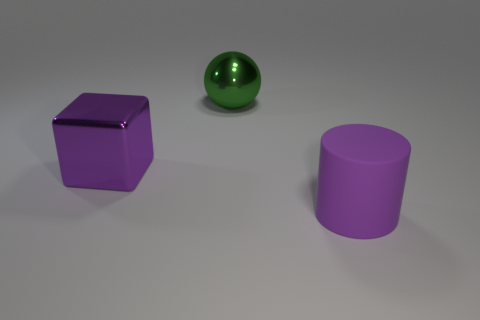There is a big object that is the same color as the big metallic cube; what is it made of?
Give a very brief answer. Rubber. Is there any other thing that is made of the same material as the large cylinder?
Your answer should be compact. No. Is the rubber cylinder the same color as the shiny cube?
Your answer should be very brief. Yes. Is there a metallic thing of the same color as the cylinder?
Keep it short and to the point. Yes. There is a metallic block that is the same color as the large cylinder; what is its size?
Provide a short and direct response. Large. There is a thing that is to the left of the large green metal sphere; is its color the same as the big object on the right side of the large green thing?
Ensure brevity in your answer.  Yes. What size is the purple rubber thing?
Your answer should be compact. Large. What number of small objects are green metallic balls or purple cylinders?
Make the answer very short. 0. What is the color of the matte cylinder that is the same size as the metal sphere?
Your answer should be very brief. Purple. What number of other things are there of the same shape as the big purple rubber thing?
Your answer should be compact. 0. 